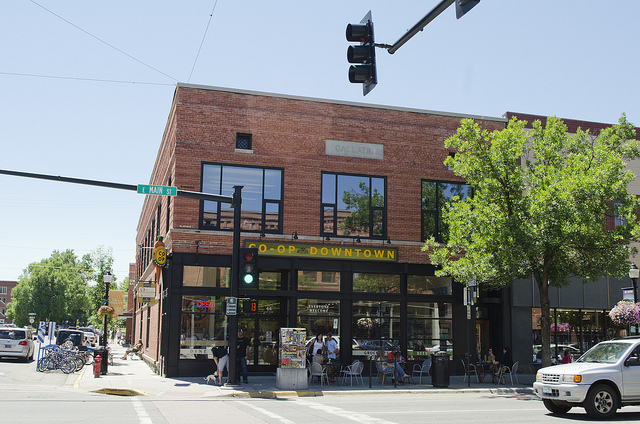Please transcribe the text in this image. O OP DOWNTOWN 